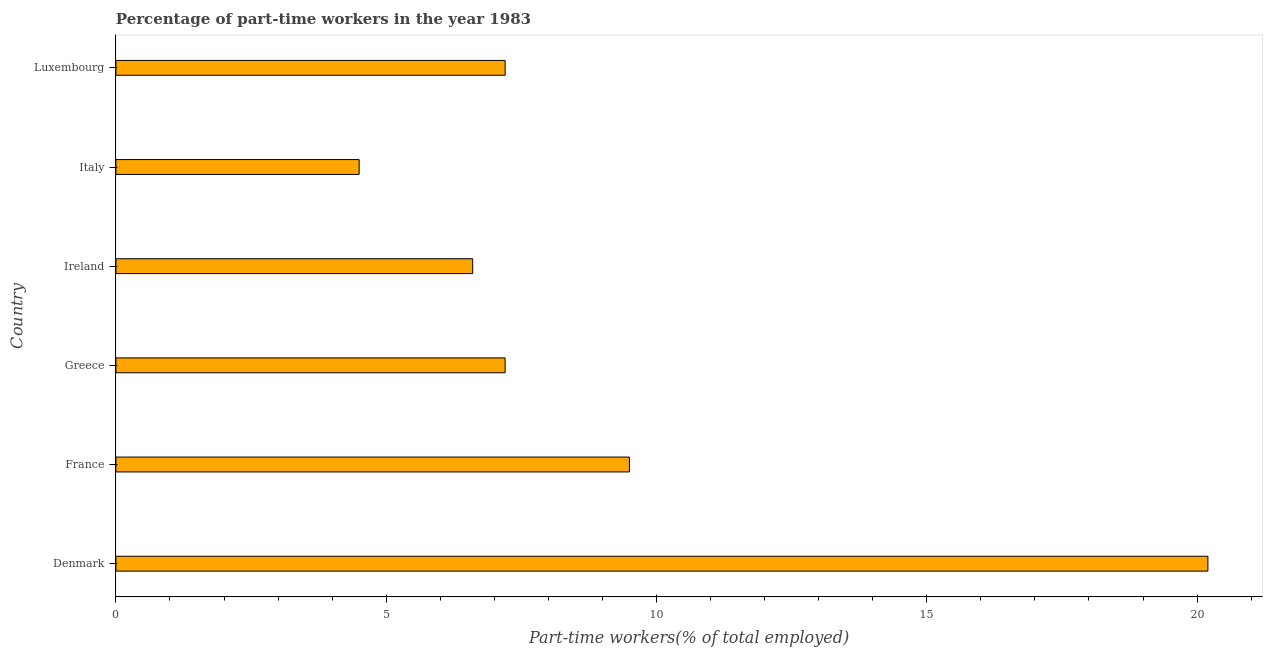Does the graph contain any zero values?
Provide a short and direct response. No. What is the title of the graph?
Provide a short and direct response. Percentage of part-time workers in the year 1983. What is the label or title of the X-axis?
Offer a terse response. Part-time workers(% of total employed). What is the label or title of the Y-axis?
Your answer should be compact. Country. What is the percentage of part-time workers in Ireland?
Your answer should be very brief. 6.6. Across all countries, what is the maximum percentage of part-time workers?
Make the answer very short. 20.2. In which country was the percentage of part-time workers minimum?
Your answer should be very brief. Italy. What is the sum of the percentage of part-time workers?
Make the answer very short. 55.2. What is the median percentage of part-time workers?
Offer a terse response. 7.2. In how many countries, is the percentage of part-time workers greater than 9 %?
Offer a very short reply. 2. What is the ratio of the percentage of part-time workers in Greece to that in Ireland?
Your answer should be very brief. 1.09. Is the percentage of part-time workers in Denmark less than that in Italy?
Your answer should be compact. No. Is the difference between the percentage of part-time workers in Ireland and Luxembourg greater than the difference between any two countries?
Provide a succinct answer. No. Is the sum of the percentage of part-time workers in Denmark and France greater than the maximum percentage of part-time workers across all countries?
Keep it short and to the point. Yes. What is the difference between the highest and the lowest percentage of part-time workers?
Provide a succinct answer. 15.7. In how many countries, is the percentage of part-time workers greater than the average percentage of part-time workers taken over all countries?
Provide a short and direct response. 2. How many bars are there?
Keep it short and to the point. 6. Are all the bars in the graph horizontal?
Give a very brief answer. Yes. How many countries are there in the graph?
Your answer should be very brief. 6. What is the Part-time workers(% of total employed) in Denmark?
Your answer should be very brief. 20.2. What is the Part-time workers(% of total employed) in France?
Offer a terse response. 9.5. What is the Part-time workers(% of total employed) in Greece?
Give a very brief answer. 7.2. What is the Part-time workers(% of total employed) of Ireland?
Keep it short and to the point. 6.6. What is the Part-time workers(% of total employed) in Luxembourg?
Your answer should be very brief. 7.2. What is the difference between the Part-time workers(% of total employed) in Denmark and France?
Your answer should be very brief. 10.7. What is the difference between the Part-time workers(% of total employed) in Denmark and Italy?
Provide a succinct answer. 15.7. What is the difference between the Part-time workers(% of total employed) in Denmark and Luxembourg?
Give a very brief answer. 13. What is the difference between the Part-time workers(% of total employed) in France and Greece?
Offer a terse response. 2.3. What is the difference between the Part-time workers(% of total employed) in Greece and Ireland?
Give a very brief answer. 0.6. What is the difference between the Part-time workers(% of total employed) in Greece and Italy?
Make the answer very short. 2.7. What is the ratio of the Part-time workers(% of total employed) in Denmark to that in France?
Make the answer very short. 2.13. What is the ratio of the Part-time workers(% of total employed) in Denmark to that in Greece?
Your response must be concise. 2.81. What is the ratio of the Part-time workers(% of total employed) in Denmark to that in Ireland?
Keep it short and to the point. 3.06. What is the ratio of the Part-time workers(% of total employed) in Denmark to that in Italy?
Your answer should be very brief. 4.49. What is the ratio of the Part-time workers(% of total employed) in Denmark to that in Luxembourg?
Keep it short and to the point. 2.81. What is the ratio of the Part-time workers(% of total employed) in France to that in Greece?
Your response must be concise. 1.32. What is the ratio of the Part-time workers(% of total employed) in France to that in Ireland?
Offer a very short reply. 1.44. What is the ratio of the Part-time workers(% of total employed) in France to that in Italy?
Provide a succinct answer. 2.11. What is the ratio of the Part-time workers(% of total employed) in France to that in Luxembourg?
Your answer should be very brief. 1.32. What is the ratio of the Part-time workers(% of total employed) in Greece to that in Ireland?
Offer a terse response. 1.09. What is the ratio of the Part-time workers(% of total employed) in Ireland to that in Italy?
Your answer should be compact. 1.47. What is the ratio of the Part-time workers(% of total employed) in Ireland to that in Luxembourg?
Ensure brevity in your answer.  0.92. 